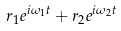Convert formula to latex. <formula><loc_0><loc_0><loc_500><loc_500>r _ { 1 } e ^ { i \omega _ { 1 } t } + r _ { 2 } e ^ { i \omega _ { 2 } t }</formula> 